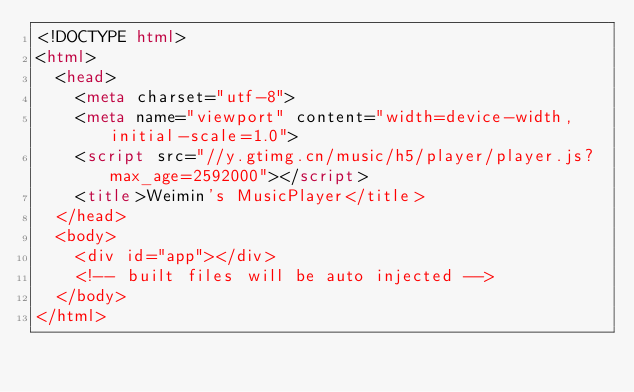Convert code to text. <code><loc_0><loc_0><loc_500><loc_500><_HTML_><!DOCTYPE html>
<html>
  <head>
    <meta charset="utf-8">
    <meta name="viewport" content="width=device-width,initial-scale=1.0">
    <script src="//y.gtimg.cn/music/h5/player/player.js?max_age=2592000"></script>
    <title>Weimin's MusicPlayer</title>
  </head>
  <body>
    <div id="app"></div>
    <!-- built files will be auto injected -->
  </body>
</html>
</code> 